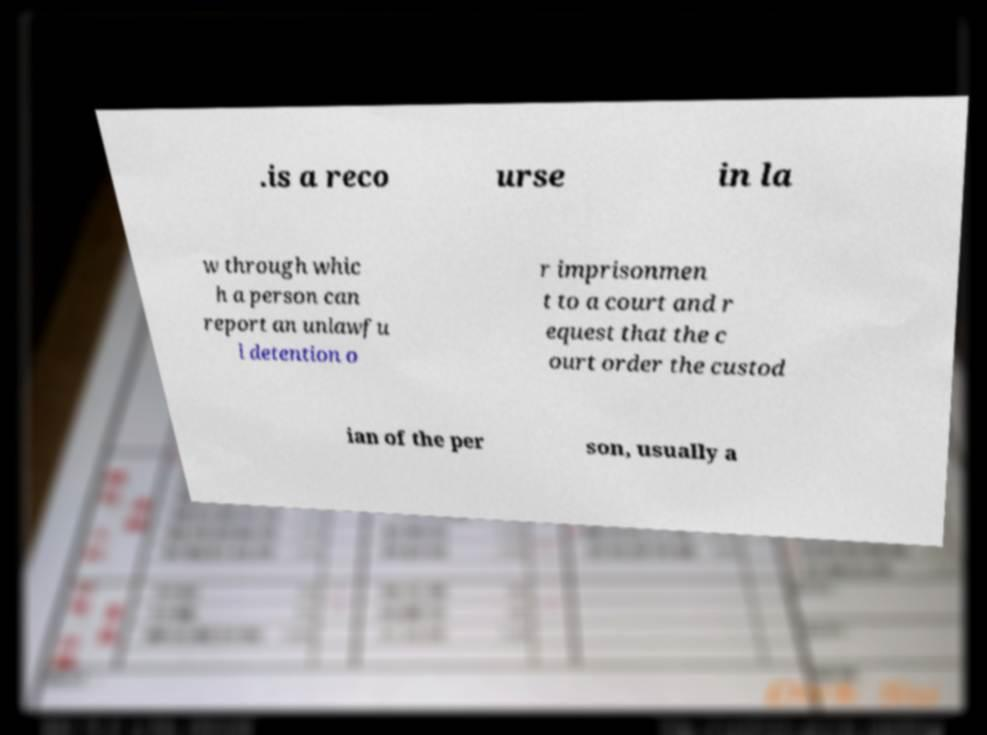For documentation purposes, I need the text within this image transcribed. Could you provide that? .is a reco urse in la w through whic h a person can report an unlawfu l detention o r imprisonmen t to a court and r equest that the c ourt order the custod ian of the per son, usually a 